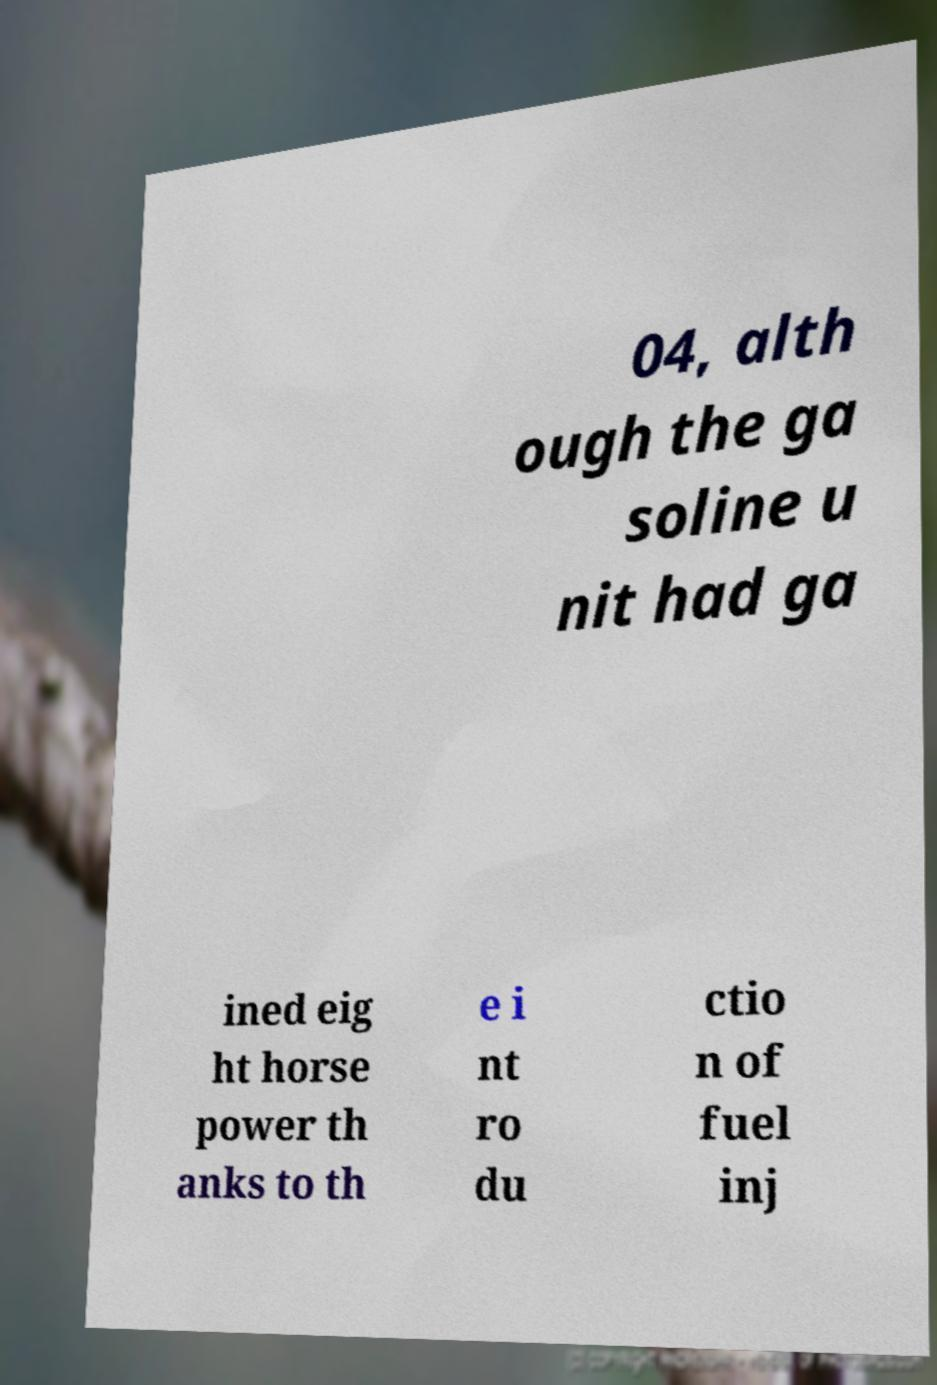Please identify and transcribe the text found in this image. 04, alth ough the ga soline u nit had ga ined eig ht horse power th anks to th e i nt ro du ctio n of fuel inj 